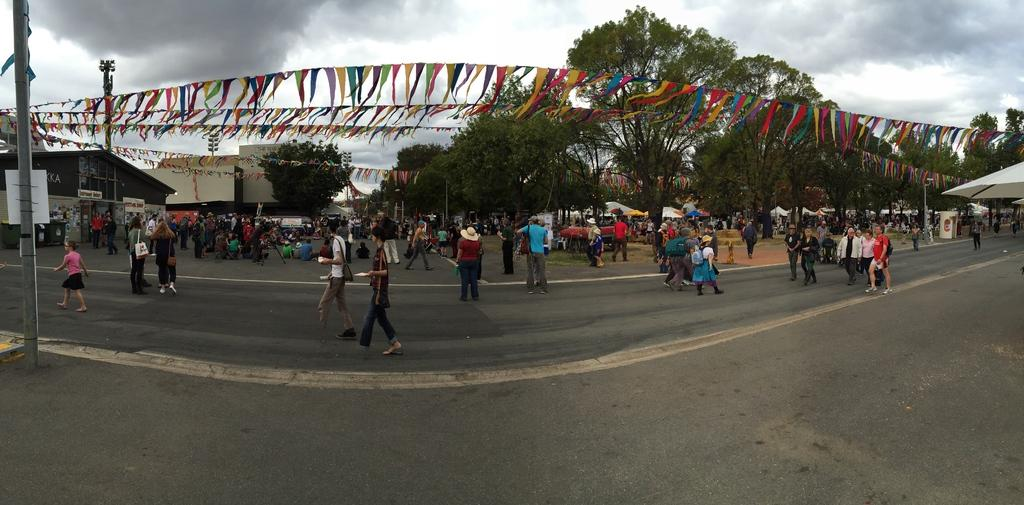How many people are in the image? There is a group of people in the image, but the exact number is not specified. Where are the people located in the image? The people are on the road in the image. What can be seen in the background of the image? There are buildings, trees, and the sky visible in the background of the image. Are there any icicles hanging from the trees in the image? There is no mention of icicles in the image, and it is unlikely that they would be present given the presence of trees and the sky. 